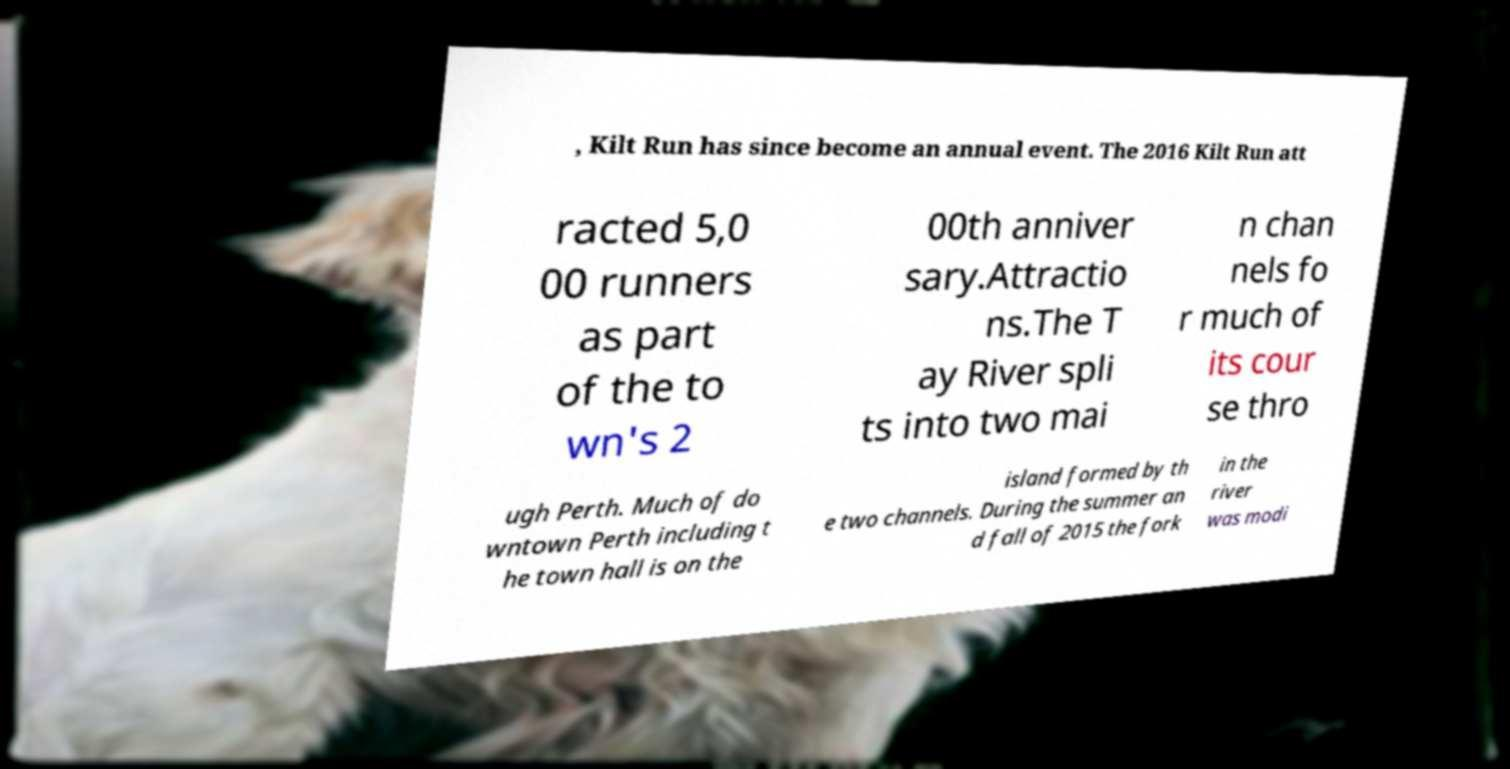There's text embedded in this image that I need extracted. Can you transcribe it verbatim? , Kilt Run has since become an annual event. The 2016 Kilt Run att racted 5,0 00 runners as part of the to wn's 2 00th anniver sary.Attractio ns.The T ay River spli ts into two mai n chan nels fo r much of its cour se thro ugh Perth. Much of do wntown Perth including t he town hall is on the island formed by th e two channels. During the summer an d fall of 2015 the fork in the river was modi 